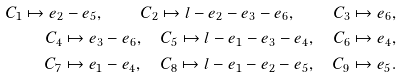<formula> <loc_0><loc_0><loc_500><loc_500>C _ { 1 } \mapsto e _ { 2 } - e _ { 5 } , \quad C _ { 2 } \mapsto l - e _ { 2 } - e _ { 3 } - e _ { 6 } , \quad C _ { 3 } \mapsto e _ { 6 } , \\ C _ { 4 } \mapsto e _ { 3 } - e _ { 6 } , \quad C _ { 5 } \mapsto l - e _ { 1 } - e _ { 3 } - e _ { 4 } , \quad C _ { 6 } \mapsto e _ { 4 } , \\ C _ { 7 } \mapsto e _ { 1 } - e _ { 4 } , \quad C _ { 8 } \mapsto l - e _ { 1 } - e _ { 2 } - e _ { 5 } , \quad C _ { 9 } \mapsto e _ { 5 } .</formula> 